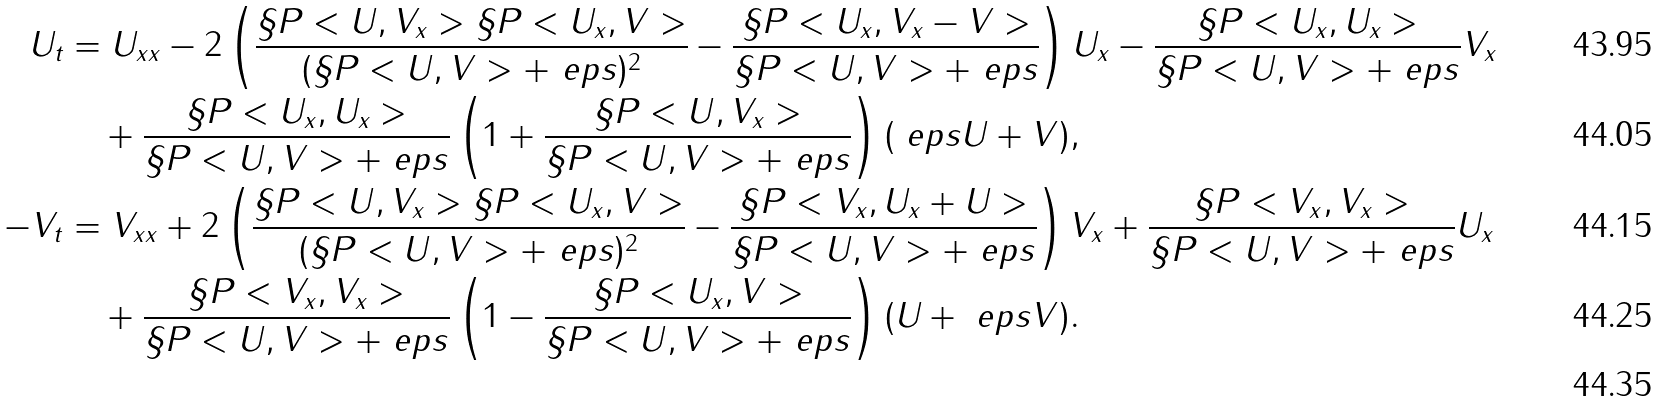<formula> <loc_0><loc_0><loc_500><loc_500>U _ { t } & = U _ { x x } - 2 \left ( \frac { \S P < U , V _ { x } > \S P < U _ { x } , V > } { ( \S P < U , V > + \ e p s ) ^ { 2 } } - \frac { \S P < U _ { x } , V _ { x } - V > } { \S P < U , V > + \ e p s } \right ) U _ { x } - \frac { \S P < U _ { x } , U _ { x } > } { \S P < U , V > + \ e p s } V _ { x } \\ & \quad + \frac { \S P < U _ { x } , U _ { x } > } { \S P < U , V > + \ e p s } \left ( 1 + \frac { \S P < U , V _ { x } > } { \S P < U , V > + \ e p s } \right ) ( \ e p s U + V ) , \\ - V _ { t } & = V _ { x x } + 2 \left ( \frac { \S P < U , V _ { x } > \S P < U _ { x } , V > } { ( \S P < U , V > + \ e p s ) ^ { 2 } } - \frac { \S P < V _ { x } , U _ { x } + U > } { \S P < U , V > + \ e p s } \right ) V _ { x } + \frac { \S P < V _ { x } , V _ { x } > } { \S P < U , V > + \ e p s } U _ { x } \\ & \quad + \frac { \S P < V _ { x } , V _ { x } > } { \S P < U , V > + \ e p s } \left ( 1 - \frac { \S P < U _ { x } , V > } { \S P < U , V > + \ e p s } \right ) ( U + \ e p s V ) . \\</formula> 